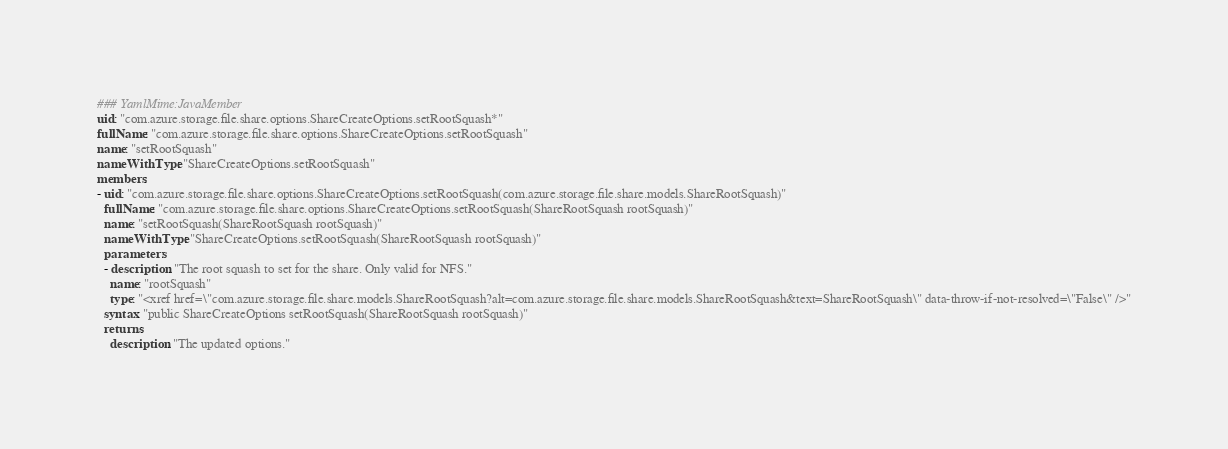<code> <loc_0><loc_0><loc_500><loc_500><_YAML_>### YamlMime:JavaMember
uid: "com.azure.storage.file.share.options.ShareCreateOptions.setRootSquash*"
fullName: "com.azure.storage.file.share.options.ShareCreateOptions.setRootSquash"
name: "setRootSquash"
nameWithType: "ShareCreateOptions.setRootSquash"
members:
- uid: "com.azure.storage.file.share.options.ShareCreateOptions.setRootSquash(com.azure.storage.file.share.models.ShareRootSquash)"
  fullName: "com.azure.storage.file.share.options.ShareCreateOptions.setRootSquash(ShareRootSquash rootSquash)"
  name: "setRootSquash(ShareRootSquash rootSquash)"
  nameWithType: "ShareCreateOptions.setRootSquash(ShareRootSquash rootSquash)"
  parameters:
  - description: "The root squash to set for the share. Only valid for NFS."
    name: "rootSquash"
    type: "<xref href=\"com.azure.storage.file.share.models.ShareRootSquash?alt=com.azure.storage.file.share.models.ShareRootSquash&text=ShareRootSquash\" data-throw-if-not-resolved=\"False\" />"
  syntax: "public ShareCreateOptions setRootSquash(ShareRootSquash rootSquash)"
  returns:
    description: "The updated options."</code> 